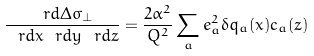Convert formula to latex. <formula><loc_0><loc_0><loc_500><loc_500>\frac { \ r d { \Delta \sigma _ { \perp } } } { \ r d x \ r d y \ r d z } = \frac { 2 \alpha ^ { 2 } } { Q ^ { 2 } } \sum _ { a } e _ { a } ^ { 2 } \delta q _ { a } ( x ) c _ { a } ( z )</formula> 